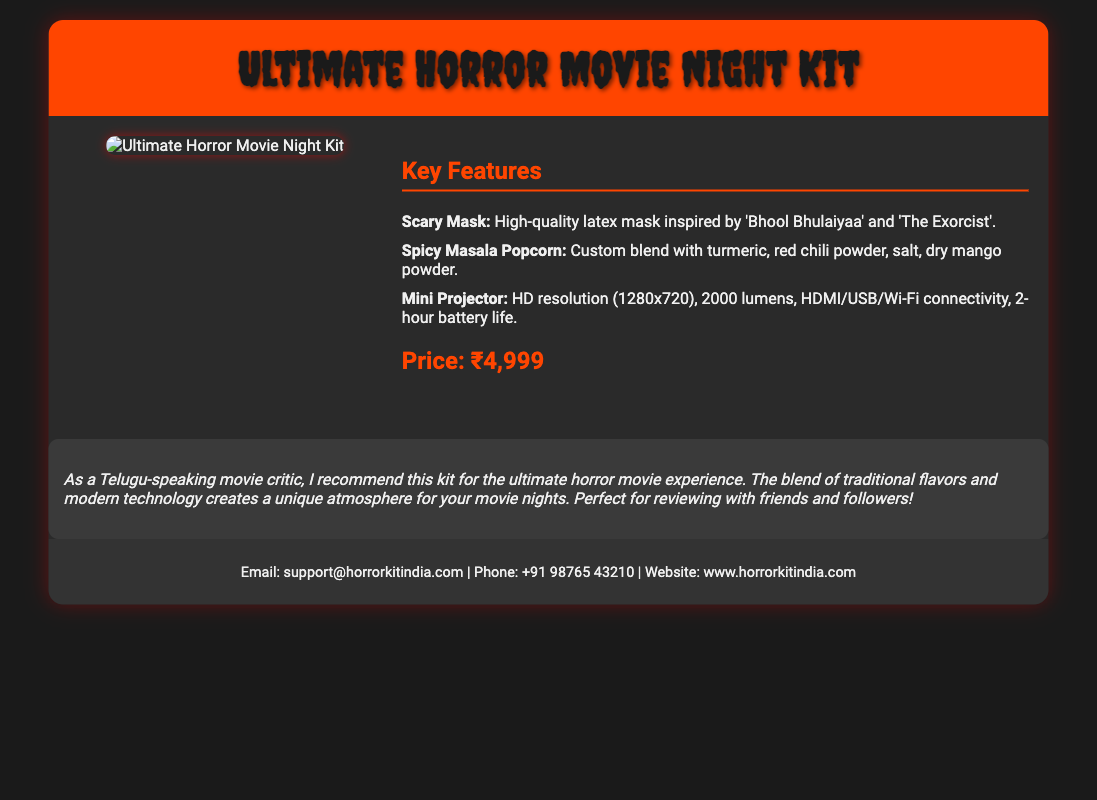What is included in the Ultimate Horror Movie Night Kit? The kit includes a scary mask, spicy masala popcorn, and a mini projector.
Answer: scary mask, spicy masala popcorn, mini projector What is the price of the kit? The document explicitly states the price of the kit.
Answer: ₹4,999 What is the battery life of the mini projector? The battery life is mentioned in the product details of the mini projector.
Answer: 2-hour Which movies inspired the design of the scary mask? The document mentions specific movies that inspired the mask design.
Answer: Bhool Bhulaiyaa, The Exorcist What connectivity options does the mini projector have? The document lists the connectivity options available for the mini projector.
Answer: HDMI/USB/Wi-Fi What spice is included in the custom blend for popcorn? The document lists specific spices that are part of the popcorn.
Answer: turmeric, red chili powder, salt, dry mango powder What is the resolution of the mini projector? The document specifies the HD resolution of the mini projector.
Answer: 1280x720 Who is the target audience suggested for the kit? The document includes a recommendation tailored for a specific audience.
Answer: Telugu-speaking movie critic 